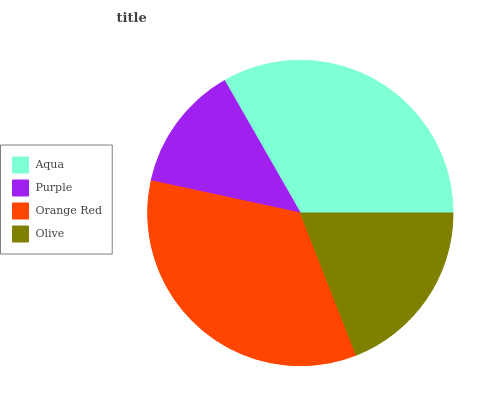Is Purple the minimum?
Answer yes or no. Yes. Is Orange Red the maximum?
Answer yes or no. Yes. Is Orange Red the minimum?
Answer yes or no. No. Is Purple the maximum?
Answer yes or no. No. Is Orange Red greater than Purple?
Answer yes or no. Yes. Is Purple less than Orange Red?
Answer yes or no. Yes. Is Purple greater than Orange Red?
Answer yes or no. No. Is Orange Red less than Purple?
Answer yes or no. No. Is Aqua the high median?
Answer yes or no. Yes. Is Olive the low median?
Answer yes or no. Yes. Is Olive the high median?
Answer yes or no. No. Is Aqua the low median?
Answer yes or no. No. 